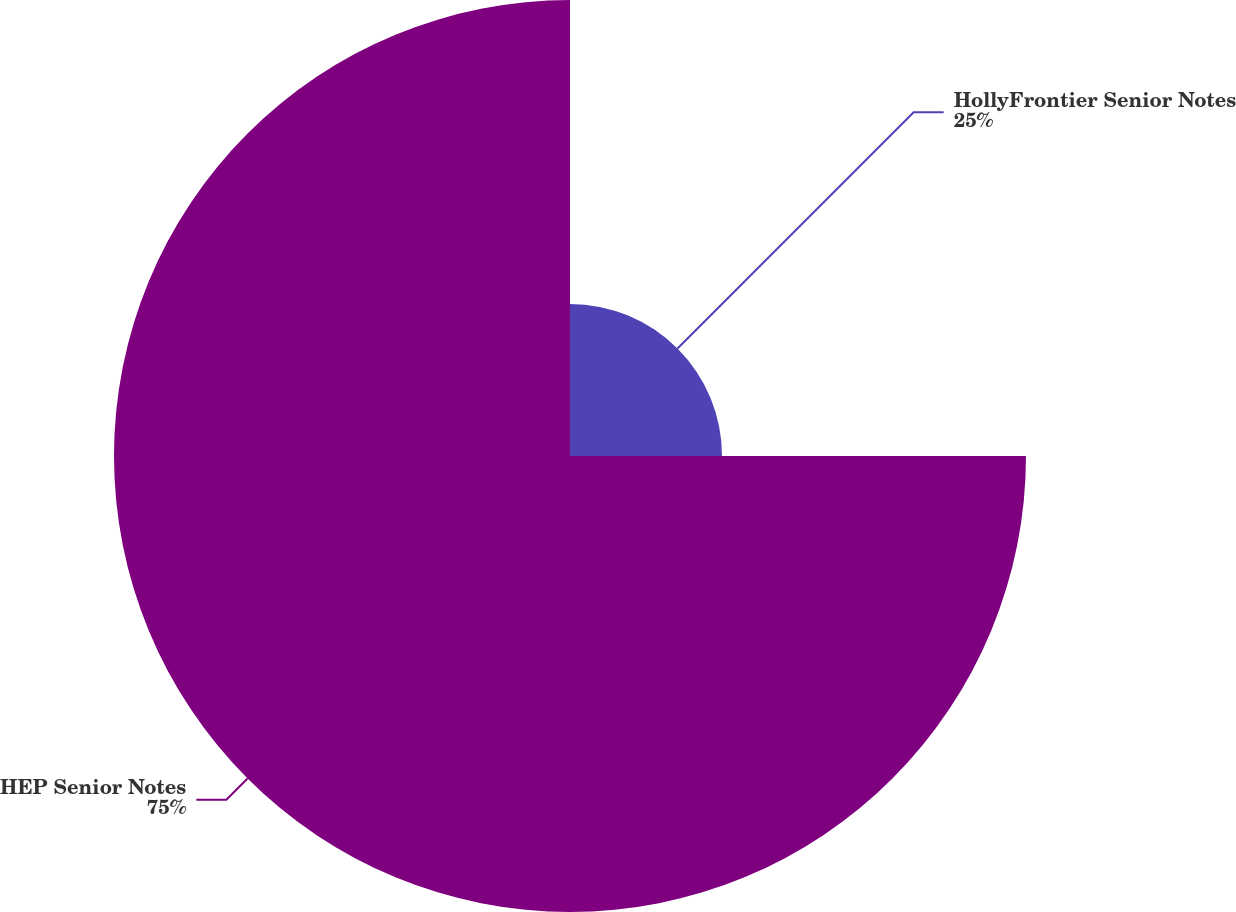Convert chart. <chart><loc_0><loc_0><loc_500><loc_500><pie_chart><fcel>HollyFrontier Senior Notes<fcel>HEP Senior Notes<nl><fcel>25.0%<fcel>75.0%<nl></chart> 